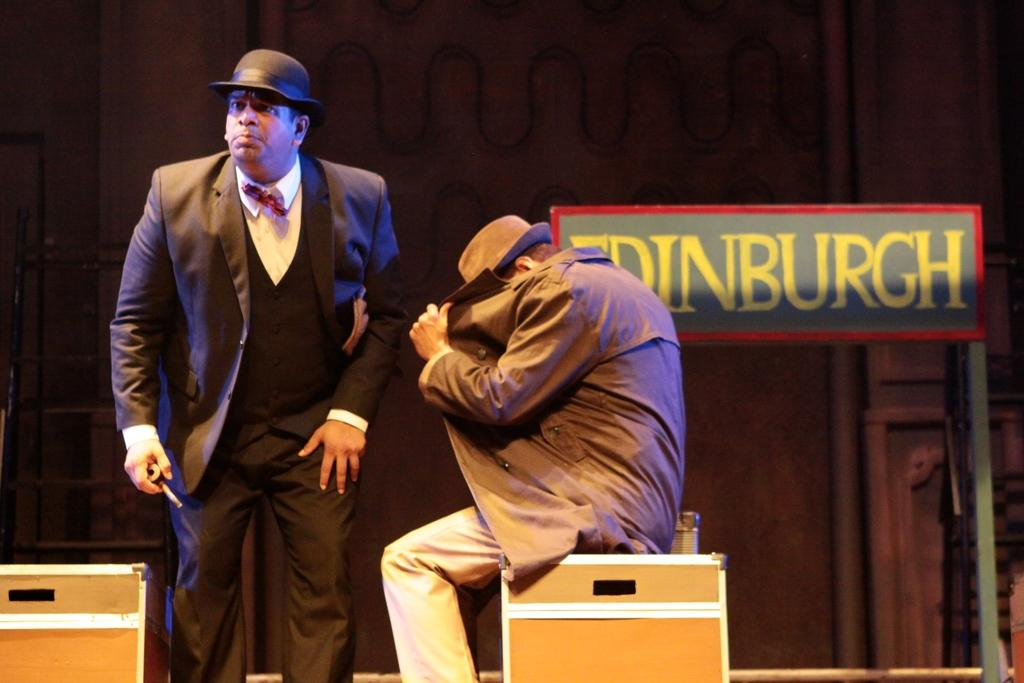What is the position of the man in the image? There is a man standing in the image. What is the man standing wearing? The man is wearing a black blazer. What is the position of the second man in the image? The second man is sitting in the image. What is the second man sitting on? The man sitting is on a wooden box. What can be seen in the background of the image? There is a board visible in the background. What is behind the people in the image? There is a wall behind the people. What type of juice is being served at the airport in the image? There is no airport or juice present in the image; it features two men, one standing and one sitting. How can the second man join the first man in the image? The second man is already present in the image, sitting on a wooden box, so there is no need for him to join the first man. 